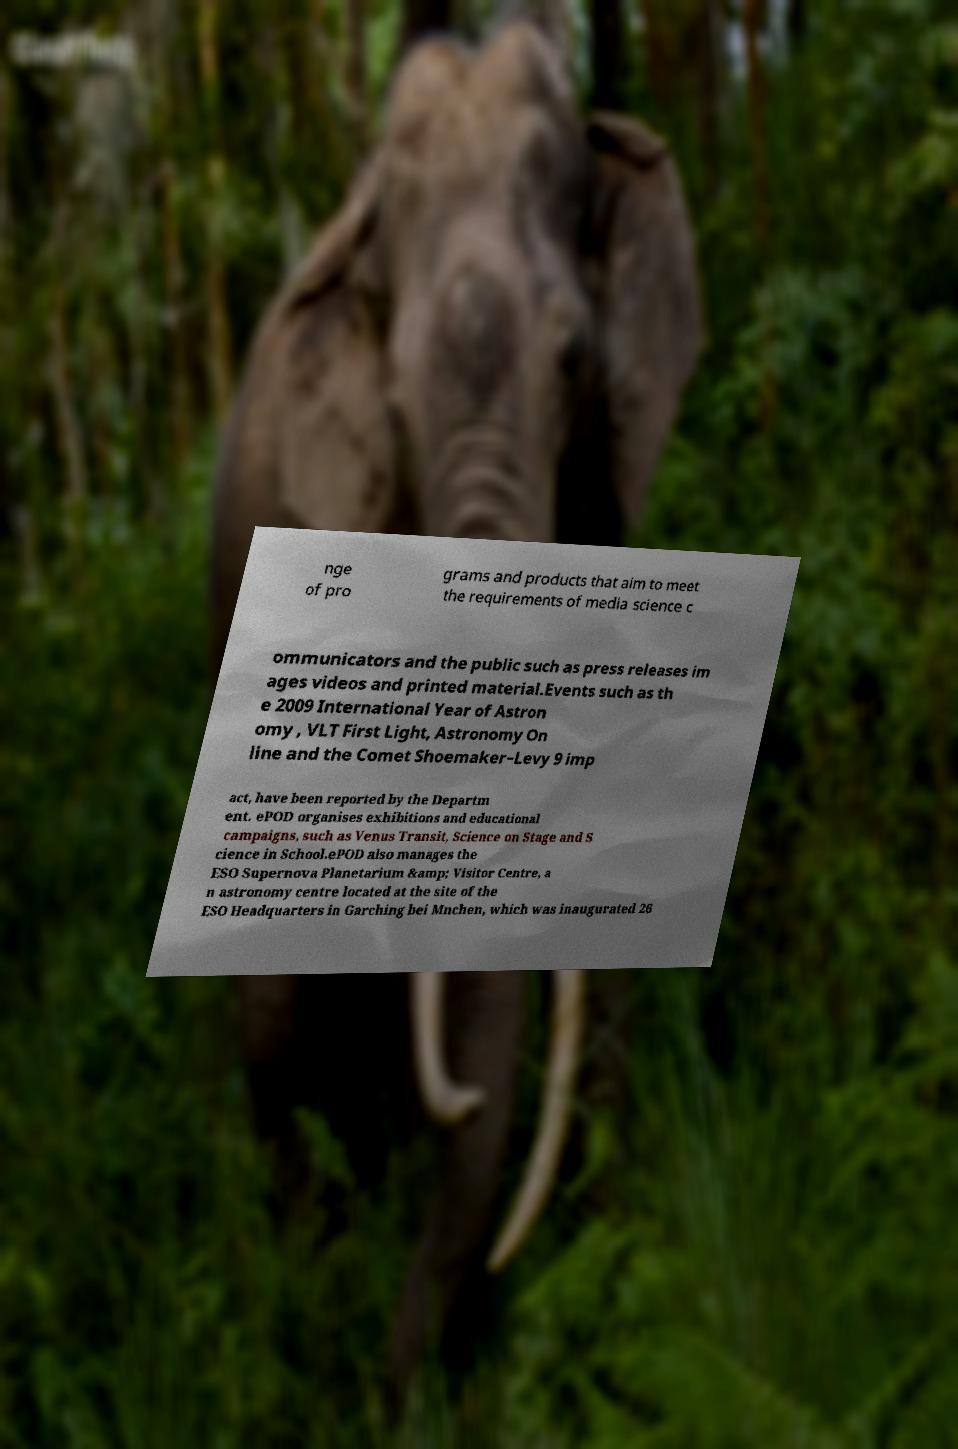Can you accurately transcribe the text from the provided image for me? nge of pro grams and products that aim to meet the requirements of media science c ommunicators and the public such as press releases im ages videos and printed material.Events such as th e 2009 International Year of Astron omy , VLT First Light, Astronomy On line and the Comet Shoemaker–Levy 9 imp act, have been reported by the Departm ent. ePOD organises exhibitions and educational campaigns, such as Venus Transit, Science on Stage and S cience in School.ePOD also manages the ESO Supernova Planetarium &amp; Visitor Centre, a n astronomy centre located at the site of the ESO Headquarters in Garching bei Mnchen, which was inaugurated 26 